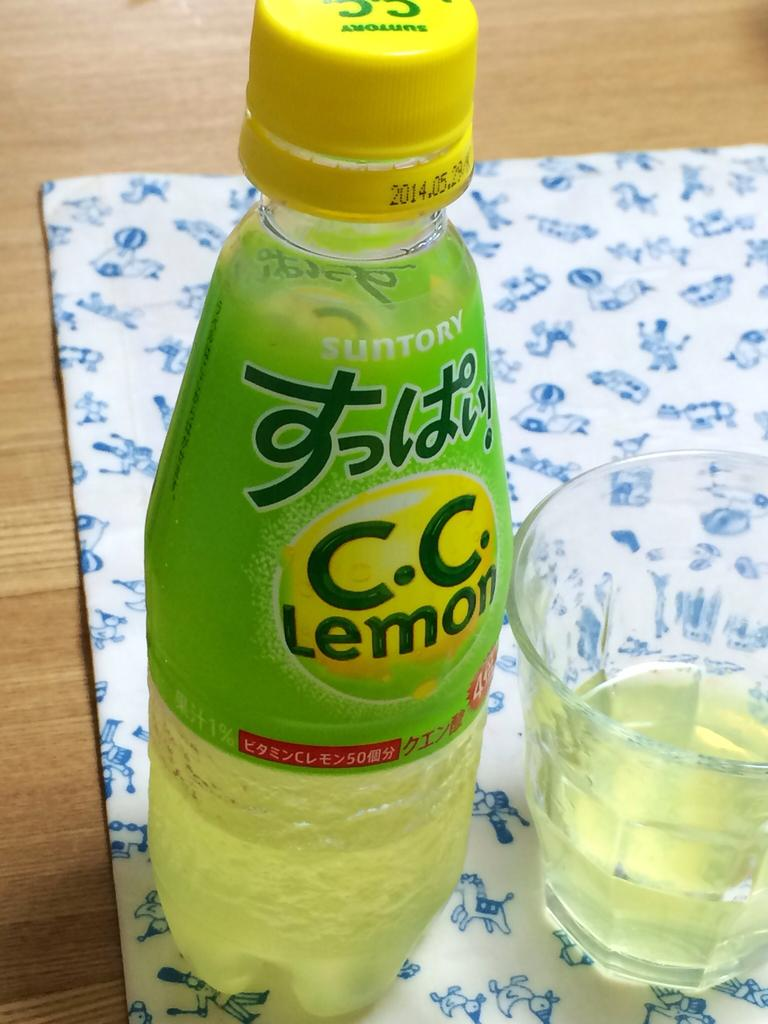<image>
Present a compact description of the photo's key features. A C.C. Lemon bottle is on a table next to a glass. 